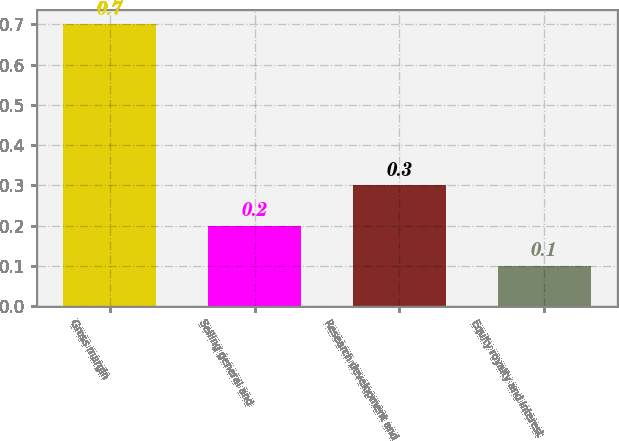Convert chart to OTSL. <chart><loc_0><loc_0><loc_500><loc_500><bar_chart><fcel>Gross margin<fcel>Selling general and<fcel>Research development and<fcel>Equity royalty and interest<nl><fcel>0.7<fcel>0.2<fcel>0.3<fcel>0.1<nl></chart> 